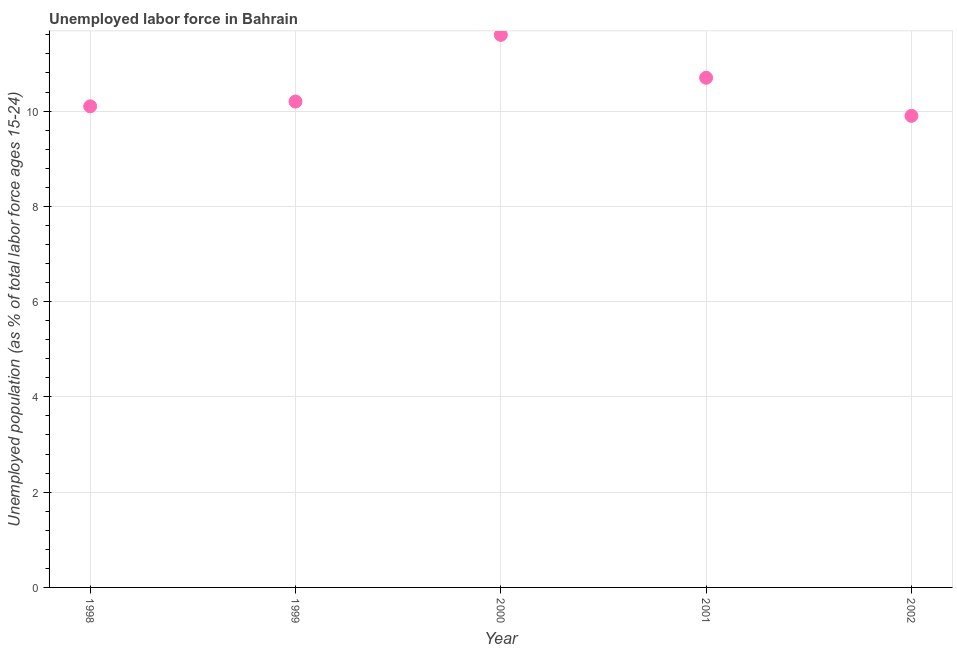What is the total unemployed youth population in 2000?
Provide a short and direct response. 11.6. Across all years, what is the maximum total unemployed youth population?
Give a very brief answer. 11.6. Across all years, what is the minimum total unemployed youth population?
Your answer should be very brief. 9.9. In which year was the total unemployed youth population maximum?
Provide a succinct answer. 2000. What is the sum of the total unemployed youth population?
Offer a very short reply. 52.5. What is the difference between the total unemployed youth population in 1999 and 2002?
Keep it short and to the point. 0.3. What is the average total unemployed youth population per year?
Ensure brevity in your answer.  10.5. What is the median total unemployed youth population?
Offer a terse response. 10.2. In how many years, is the total unemployed youth population greater than 6.4 %?
Provide a succinct answer. 5. Do a majority of the years between 1999 and 2002 (inclusive) have total unemployed youth population greater than 7.2 %?
Provide a succinct answer. Yes. What is the ratio of the total unemployed youth population in 2000 to that in 2001?
Provide a succinct answer. 1.08. Is the total unemployed youth population in 1999 less than that in 2002?
Ensure brevity in your answer.  No. What is the difference between the highest and the second highest total unemployed youth population?
Provide a succinct answer. 0.9. What is the difference between the highest and the lowest total unemployed youth population?
Offer a terse response. 1.7. How many dotlines are there?
Your answer should be compact. 1. Are the values on the major ticks of Y-axis written in scientific E-notation?
Your answer should be compact. No. Does the graph contain any zero values?
Your response must be concise. No. What is the title of the graph?
Give a very brief answer. Unemployed labor force in Bahrain. What is the label or title of the X-axis?
Your answer should be compact. Year. What is the label or title of the Y-axis?
Offer a terse response. Unemployed population (as % of total labor force ages 15-24). What is the Unemployed population (as % of total labor force ages 15-24) in 1998?
Offer a very short reply. 10.1. What is the Unemployed population (as % of total labor force ages 15-24) in 1999?
Ensure brevity in your answer.  10.2. What is the Unemployed population (as % of total labor force ages 15-24) in 2000?
Your answer should be compact. 11.6. What is the Unemployed population (as % of total labor force ages 15-24) in 2001?
Give a very brief answer. 10.7. What is the Unemployed population (as % of total labor force ages 15-24) in 2002?
Offer a very short reply. 9.9. What is the difference between the Unemployed population (as % of total labor force ages 15-24) in 1998 and 1999?
Your response must be concise. -0.1. What is the difference between the Unemployed population (as % of total labor force ages 15-24) in 1998 and 2001?
Your answer should be compact. -0.6. What is the difference between the Unemployed population (as % of total labor force ages 15-24) in 1998 and 2002?
Offer a very short reply. 0.2. What is the difference between the Unemployed population (as % of total labor force ages 15-24) in 1999 and 2000?
Your response must be concise. -1.4. What is the difference between the Unemployed population (as % of total labor force ages 15-24) in 1999 and 2002?
Provide a succinct answer. 0.3. What is the difference between the Unemployed population (as % of total labor force ages 15-24) in 2000 and 2001?
Your answer should be compact. 0.9. What is the ratio of the Unemployed population (as % of total labor force ages 15-24) in 1998 to that in 1999?
Offer a very short reply. 0.99. What is the ratio of the Unemployed population (as % of total labor force ages 15-24) in 1998 to that in 2000?
Keep it short and to the point. 0.87. What is the ratio of the Unemployed population (as % of total labor force ages 15-24) in 1998 to that in 2001?
Give a very brief answer. 0.94. What is the ratio of the Unemployed population (as % of total labor force ages 15-24) in 1999 to that in 2000?
Your response must be concise. 0.88. What is the ratio of the Unemployed population (as % of total labor force ages 15-24) in 1999 to that in 2001?
Provide a succinct answer. 0.95. What is the ratio of the Unemployed population (as % of total labor force ages 15-24) in 2000 to that in 2001?
Your answer should be very brief. 1.08. What is the ratio of the Unemployed population (as % of total labor force ages 15-24) in 2000 to that in 2002?
Your answer should be compact. 1.17. What is the ratio of the Unemployed population (as % of total labor force ages 15-24) in 2001 to that in 2002?
Provide a succinct answer. 1.08. 